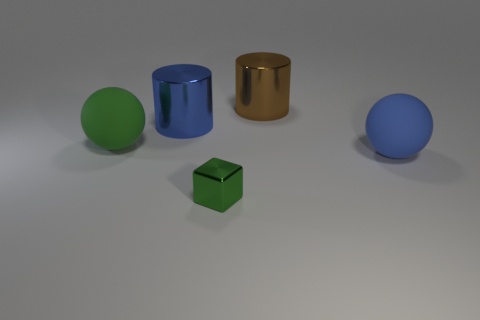Add 5 tiny brown matte cylinders. How many objects exist? 10 Subtract all cylinders. How many objects are left? 3 Subtract all tiny green metal things. Subtract all small green blocks. How many objects are left? 3 Add 3 big brown things. How many big brown things are left? 4 Add 1 brown metal objects. How many brown metal objects exist? 2 Subtract 0 cyan blocks. How many objects are left? 5 